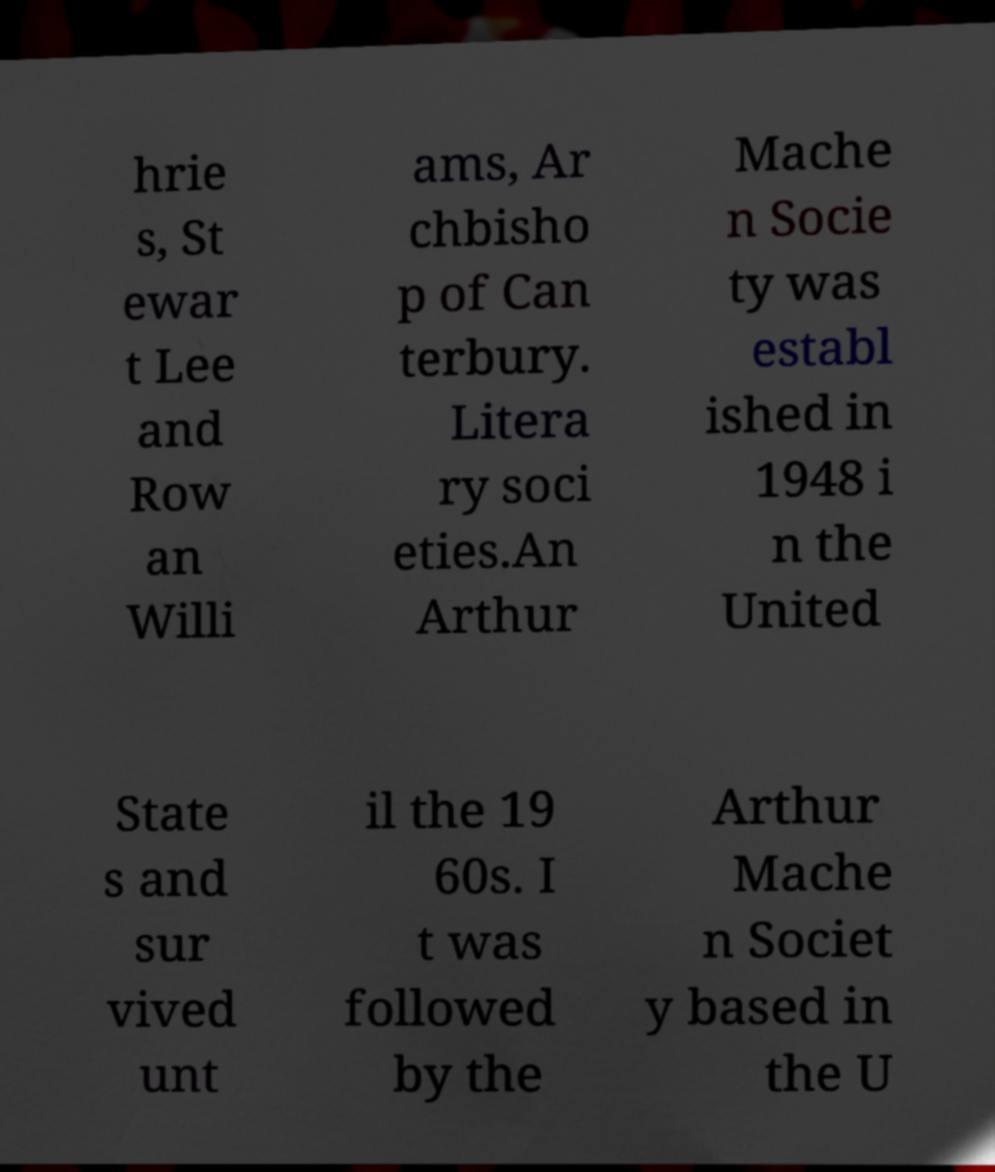Can you read and provide the text displayed in the image?This photo seems to have some interesting text. Can you extract and type it out for me? hrie s, St ewar t Lee and Row an Willi ams, Ar chbisho p of Can terbury. Litera ry soci eties.An Arthur Mache n Socie ty was establ ished in 1948 i n the United State s and sur vived unt il the 19 60s. I t was followed by the Arthur Mache n Societ y based in the U 